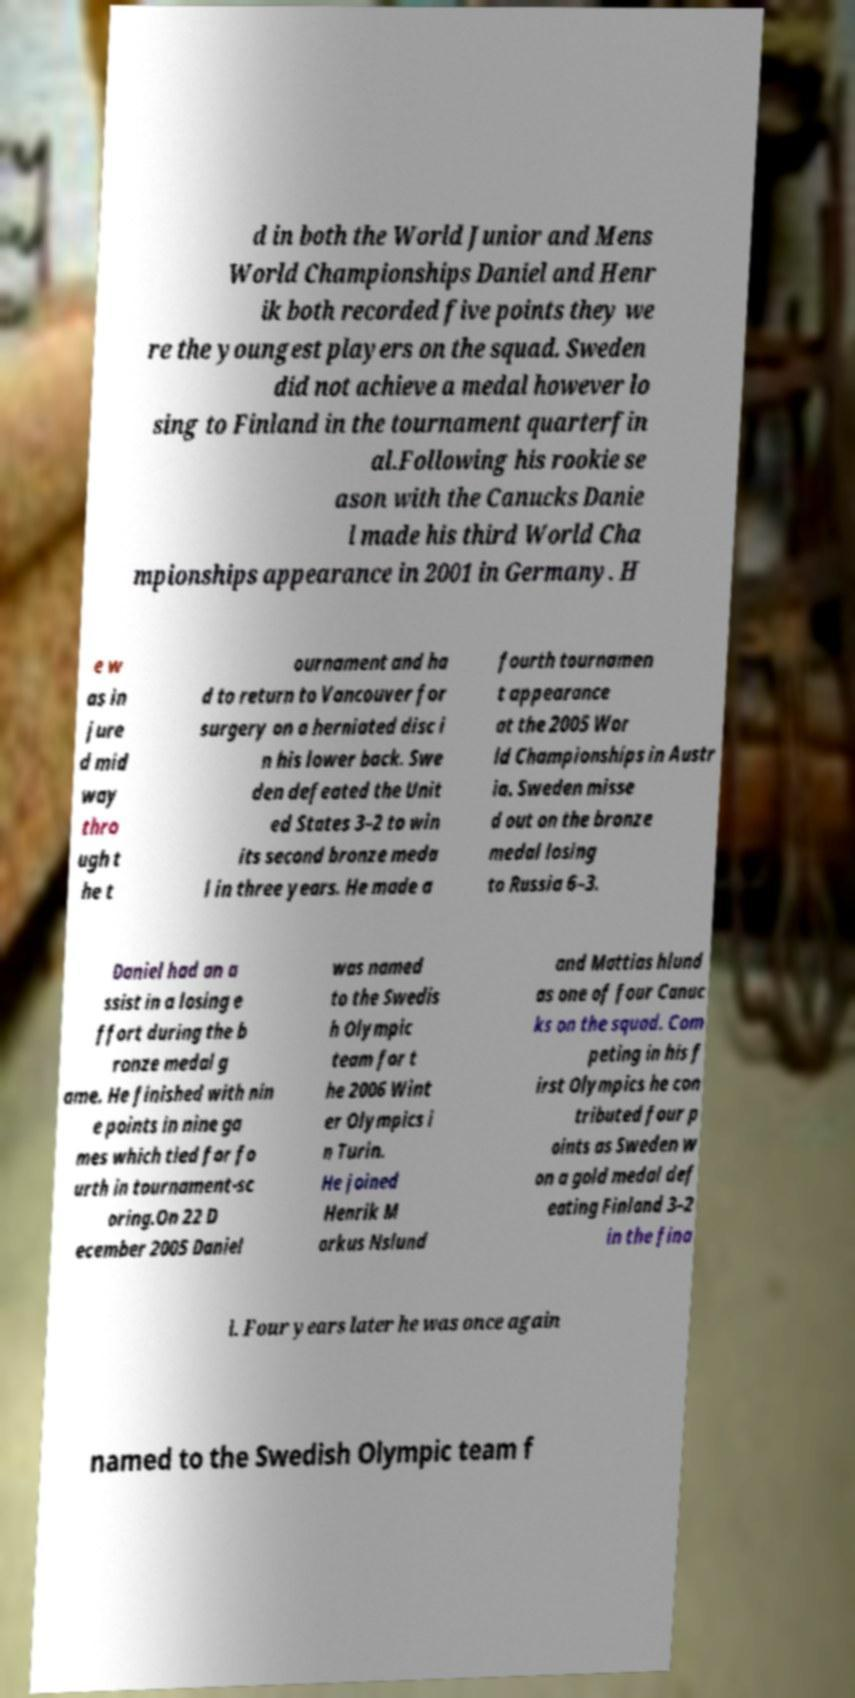Please read and relay the text visible in this image. What does it say? d in both the World Junior and Mens World Championships Daniel and Henr ik both recorded five points they we re the youngest players on the squad. Sweden did not achieve a medal however lo sing to Finland in the tournament quarterfin al.Following his rookie se ason with the Canucks Danie l made his third World Cha mpionships appearance in 2001 in Germany. H e w as in jure d mid way thro ugh t he t ournament and ha d to return to Vancouver for surgery on a herniated disc i n his lower back. Swe den defeated the Unit ed States 3–2 to win its second bronze meda l in three years. He made a fourth tournamen t appearance at the 2005 Wor ld Championships in Austr ia. Sweden misse d out on the bronze medal losing to Russia 6–3. Daniel had an a ssist in a losing e ffort during the b ronze medal g ame. He finished with nin e points in nine ga mes which tied for fo urth in tournament-sc oring.On 22 D ecember 2005 Daniel was named to the Swedis h Olympic team for t he 2006 Wint er Olympics i n Turin. He joined Henrik M arkus Nslund and Mattias hlund as one of four Canuc ks on the squad. Com peting in his f irst Olympics he con tributed four p oints as Sweden w on a gold medal def eating Finland 3–2 in the fina l. Four years later he was once again named to the Swedish Olympic team f 